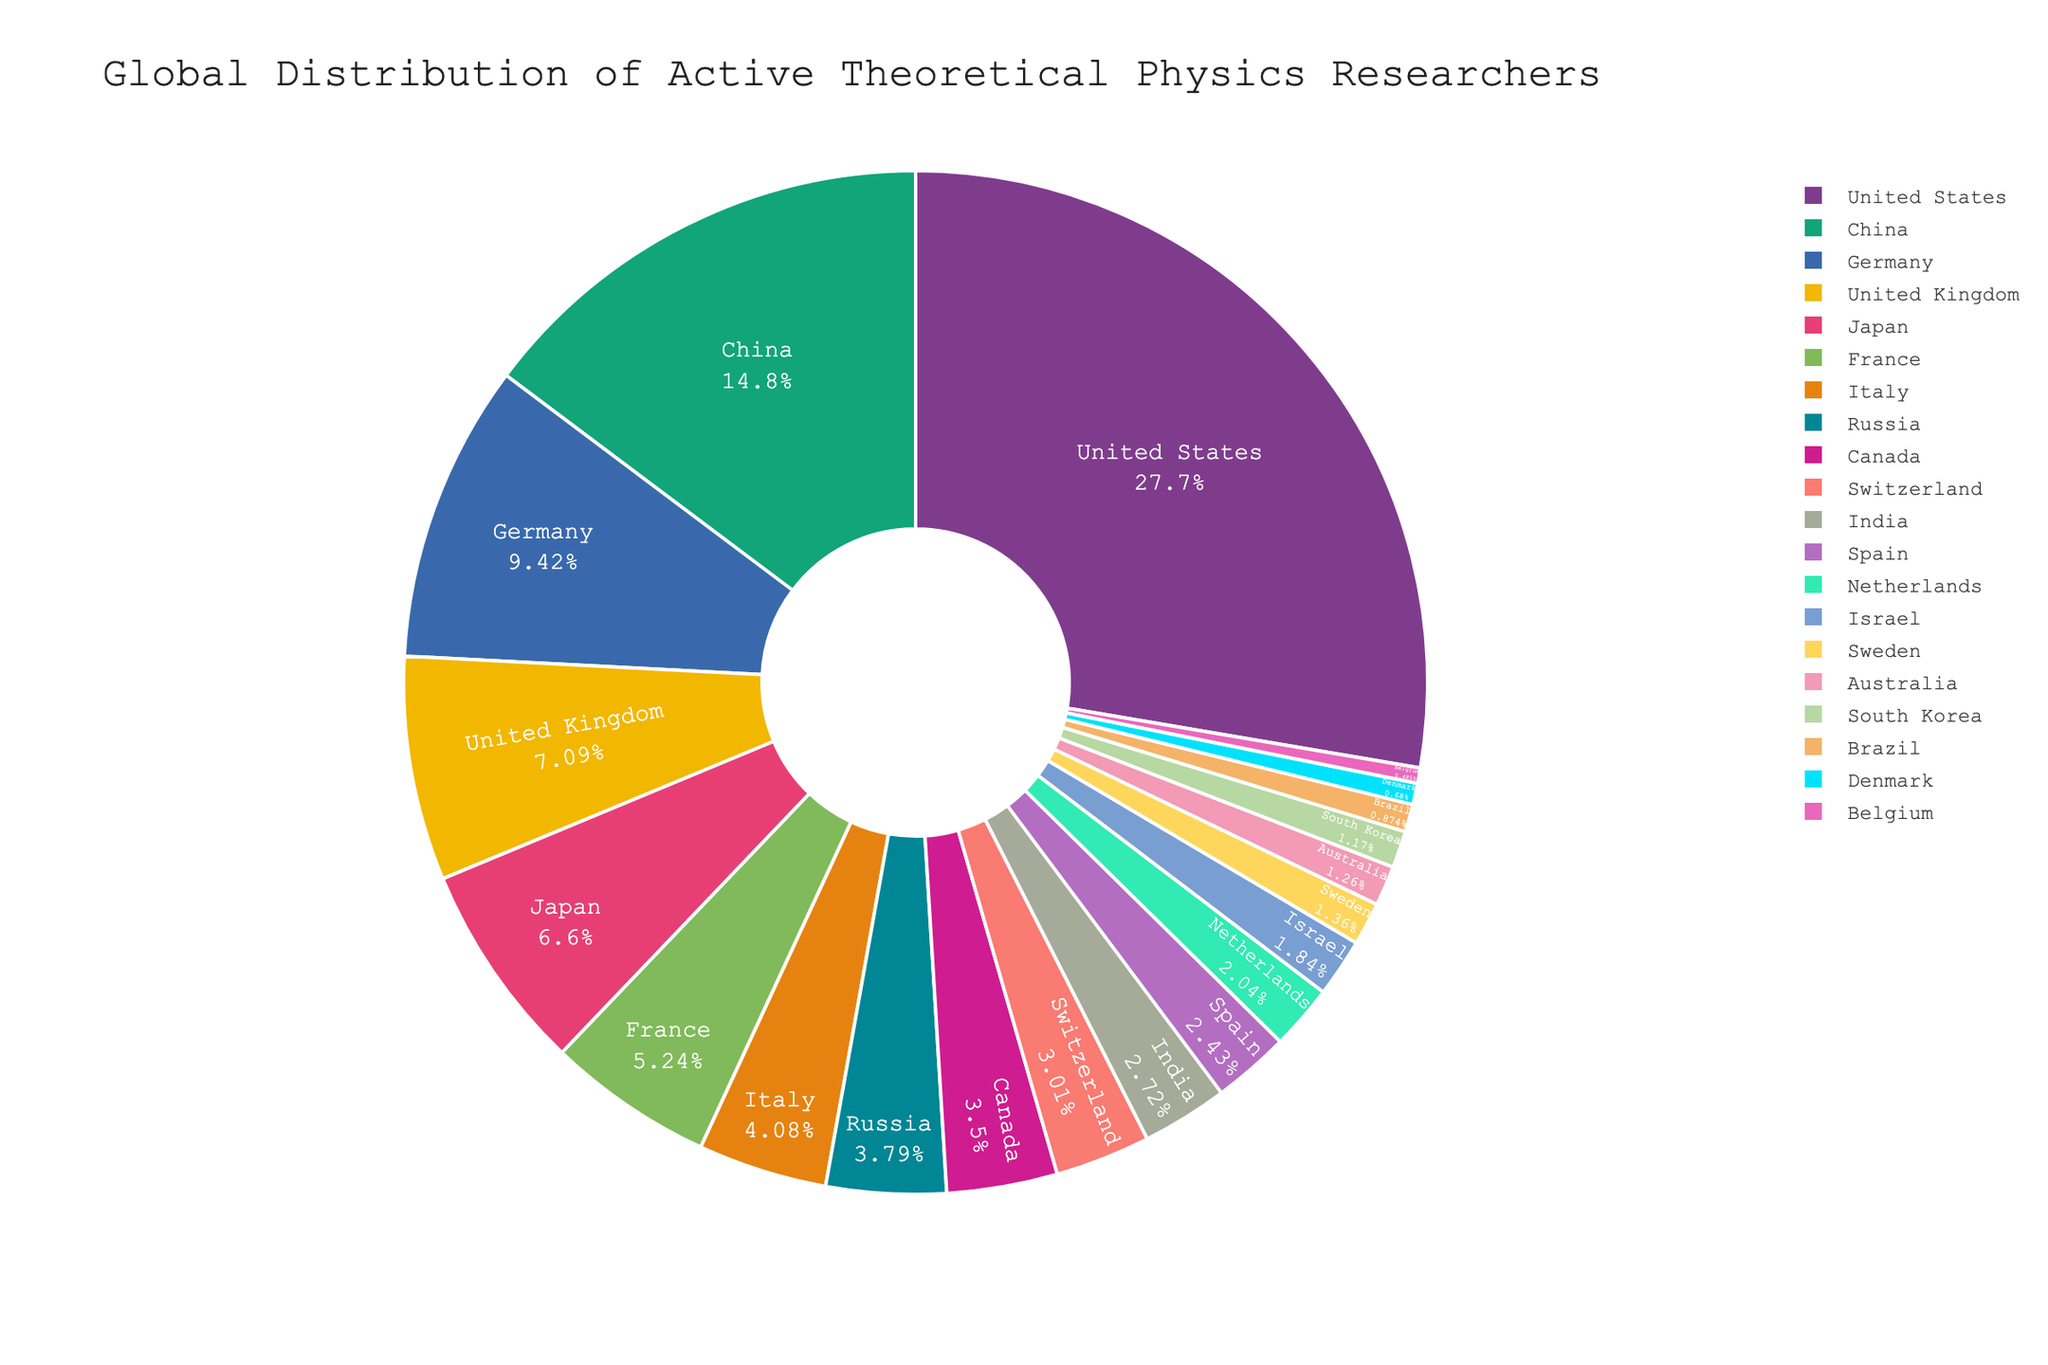What percentage of active theoretical physics researchers are from the top three countries combined? To find the combined percentage of active theoretical physics researchers from the top three countries, sum the percentages of the United States (28.5%), China (15.2%), and Germany (9.7%). So, 28.5 + 15.2 + 9.7 = 53.4%.
Answer: 53.4% Which country has a higher percentage of active researchers, United Kingdom or France? To answer this question, compare the percentages of the United Kingdom (7.3%) and France (5.4%). The United Kingdom has a higher percentage.
Answer: United Kingdom What is the combined percentage of active researchers from Italy, Russia, and Canada? Sum the individual percentages for Italy (4.2%), Russia (3.9%), and Canada (3.6%). So, 4.2 + 3.9 + 3.6 = 11.7%.
Answer: 11.7% Who has a larger share of active theoretical physics researchers: Switzerland or Spain? Compare the percentages: Switzerland has 3.1% and Spain has 2.5%. Switzerland has a larger share.
Answer: Switzerland What is the total percentage of active researchers from the countries with less than 2% each? Sum the percentages of countries with less than 2%: India (2.8%), Spain (2.5%), Netherlands (2.1%), Israel (1.9%), Sweden (1.4%), Australia (1.3%), South Korea (1.2%), Brazil (0.9%), Denmark (0.7%), and Belgium (0.5%). Total = 2.8 + 2.5 + 2.1 + 1.9 + 1.4 + 1.3 + 1.2 + 0.9 + 0.7 + 0.5 = 15.3%.
Answer: 15.3% How much larger is the percentage of active researchers in China compared to Japan? Subtract Japan's percentage (6.8%) from China's percentage (15.2%). So, 15.2 - 6.8 = 8.4%.
Answer: 8.4% Which countries have a percentage difference of 1% or less from each other? Check pairs of countries for percentage differences of 1% or less: Japan (6.8%) and United Kingdom (7.3%) have a difference of 0.5%, Russia (3.9%) and Canada (3.6%) have a difference of 0.3%, Spain (2.5%) and India (2.8%) have a difference of 0.3%, Israel (1.9%) and Netherlands (2.1%) have a difference of 0.2%, Sweden (1.4%) and Australia (1.3%) have a difference of 0.1%.
Answer: Japan-UK, Russia-Canada, Spain-India, Israel-Netherlands, Sweden-Australia 